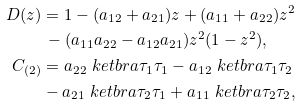Convert formula to latex. <formula><loc_0><loc_0><loc_500><loc_500>D ( z ) & = 1 - ( a _ { 1 2 } + a _ { 2 1 } ) z + ( a _ { 1 1 } + a _ { 2 2 } ) z ^ { 2 } \\ & \, - ( a _ { 1 1 } a _ { 2 2 } - a _ { 1 2 } a _ { 2 1 } ) z ^ { 2 } ( 1 - z ^ { 2 } ) , \\ C _ { ( 2 ) } & = a _ { 2 2 } \ k e t b r a { \tau _ { 1 } } { \tau _ { 1 } } - a _ { 1 2 } \ k e t b r a { \tau _ { 1 } } { \tau _ { 2 } } \\ & - a _ { 2 1 } \ k e t b r a { \tau _ { 2 } } { \tau _ { 1 } } + a _ { 1 1 } \ k e t b r a { \tau _ { 2 } } { \tau _ { 2 } } ,</formula> 